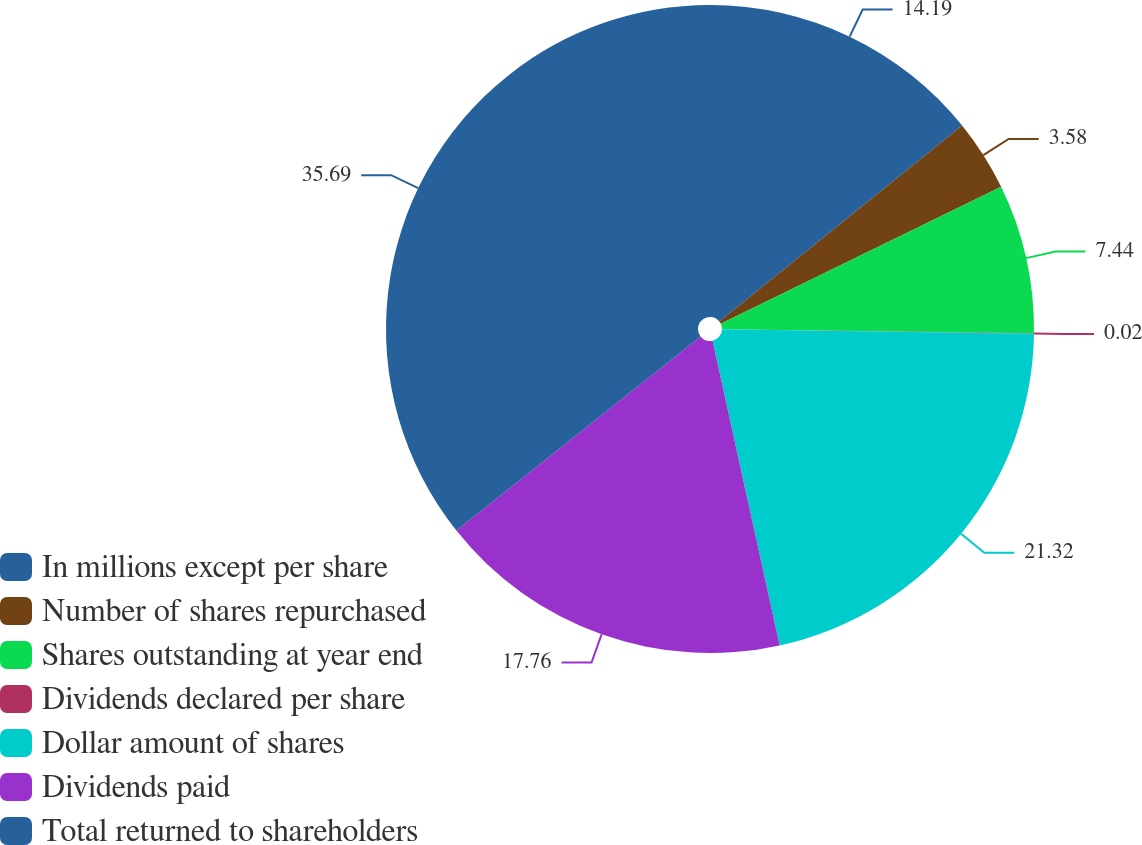<chart> <loc_0><loc_0><loc_500><loc_500><pie_chart><fcel>In millions except per share<fcel>Number of shares repurchased<fcel>Shares outstanding at year end<fcel>Dividends declared per share<fcel>Dollar amount of shares<fcel>Dividends paid<fcel>Total returned to shareholders<nl><fcel>14.19%<fcel>3.58%<fcel>7.44%<fcel>0.02%<fcel>21.32%<fcel>17.76%<fcel>35.69%<nl></chart> 